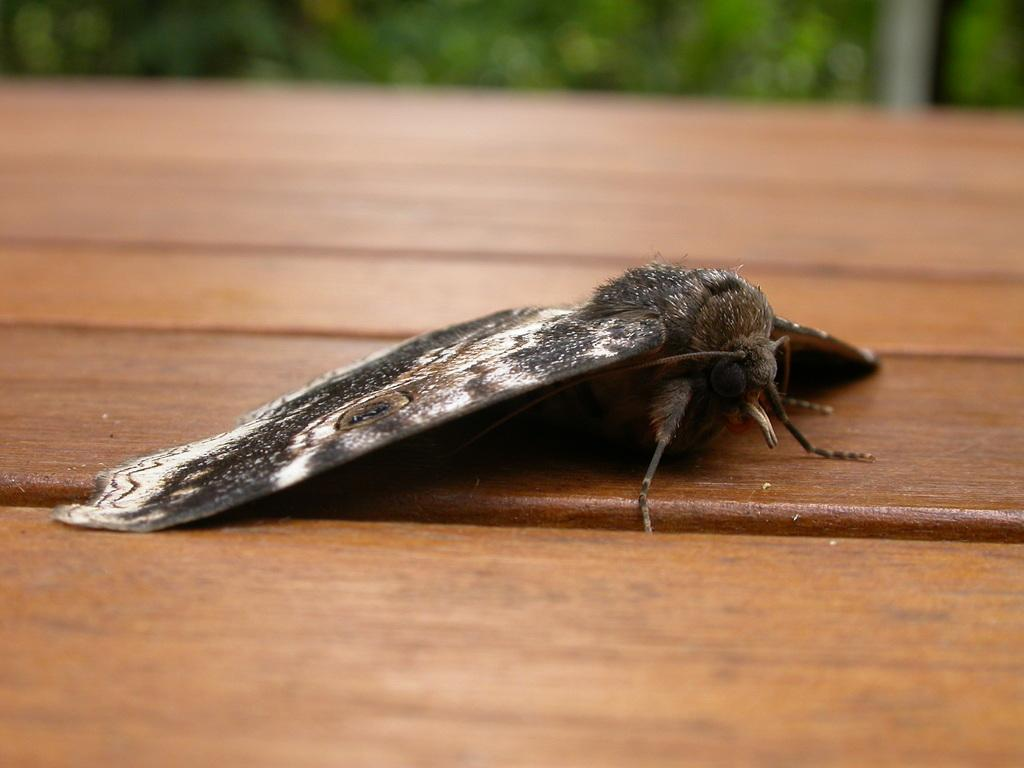What is located on the wooden table in the image? There is an insect on the wooden table in the image. What can be seen that resembles a pole in the image? There is a white object that resembles a pole in the image. What type of vegetation is present on the ground in the image? There are trees on the ground in the image. What type of seed is the farmer planting in the image? There is no farmer or seed present in the image; it features an insect on a wooden table and a white object resembling a pole. What is the slope of the hill in the image? There is no hill or slope present in the image. 